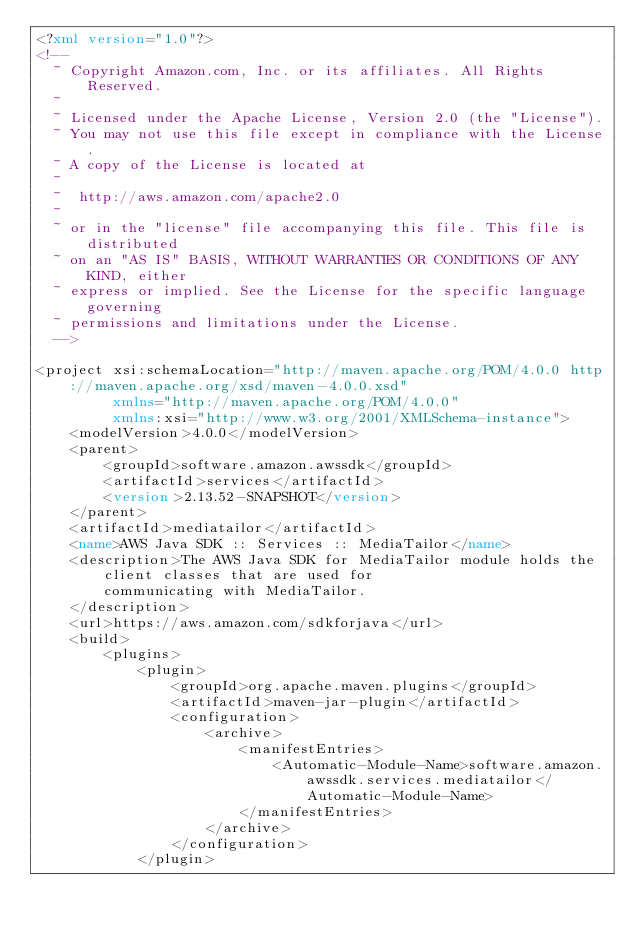<code> <loc_0><loc_0><loc_500><loc_500><_XML_><?xml version="1.0"?>
<!--
  ~ Copyright Amazon.com, Inc. or its affiliates. All Rights Reserved.
  ~
  ~ Licensed under the Apache License, Version 2.0 (the "License").
  ~ You may not use this file except in compliance with the License.
  ~ A copy of the License is located at
  ~
  ~  http://aws.amazon.com/apache2.0
  ~
  ~ or in the "license" file accompanying this file. This file is distributed
  ~ on an "AS IS" BASIS, WITHOUT WARRANTIES OR CONDITIONS OF ANY KIND, either
  ~ express or implied. See the License for the specific language governing
  ~ permissions and limitations under the License.
  -->

<project xsi:schemaLocation="http://maven.apache.org/POM/4.0.0 http://maven.apache.org/xsd/maven-4.0.0.xsd"
         xmlns="http://maven.apache.org/POM/4.0.0"
         xmlns:xsi="http://www.w3.org/2001/XMLSchema-instance">
    <modelVersion>4.0.0</modelVersion>
    <parent>
        <groupId>software.amazon.awssdk</groupId>
        <artifactId>services</artifactId>
        <version>2.13.52-SNAPSHOT</version>
    </parent>
    <artifactId>mediatailor</artifactId>
    <name>AWS Java SDK :: Services :: MediaTailor</name>
    <description>The AWS Java SDK for MediaTailor module holds the client classes that are used for
        communicating with MediaTailor.
    </description>
    <url>https://aws.amazon.com/sdkforjava</url>
    <build>
        <plugins>
            <plugin>
                <groupId>org.apache.maven.plugins</groupId>
                <artifactId>maven-jar-plugin</artifactId>
                <configuration>
                    <archive>
                        <manifestEntries>
                            <Automatic-Module-Name>software.amazon.awssdk.services.mediatailor</Automatic-Module-Name>
                        </manifestEntries>
                    </archive>
                </configuration>
            </plugin></code> 